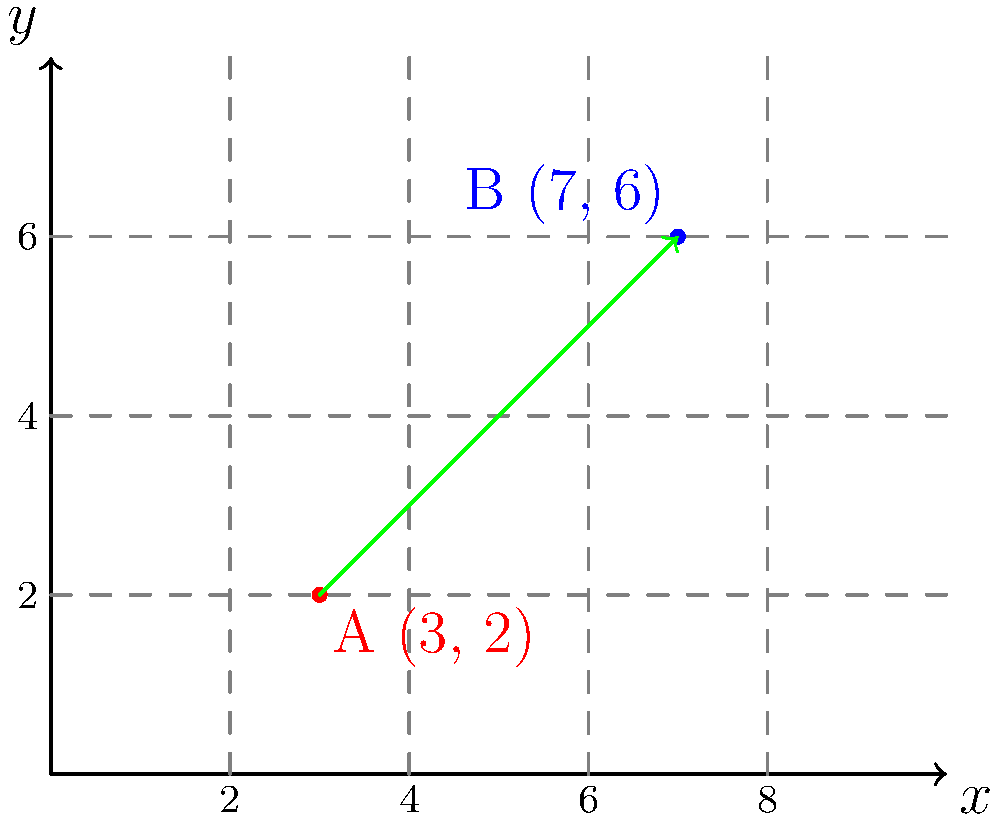Two historical weather stations, A and B, are located on a map with vector coordinates A(3, 2) and B(7, 6) respectively. Calculate the distance between these two stations using the given coordinates. To calculate the distance between two points on a coordinate plane, we can use the distance formula, which is derived from the Pythagorean theorem:

$d = \sqrt{(x_2 - x_1)^2 + (y_2 - y_1)^2}$

Where $(x_1, y_1)$ are the coordinates of the first point and $(x_2, y_2)$ are the coordinates of the second point.

Let's solve this step by step:

1) Identify the coordinates:
   Point A: $(x_1, y_1) = (3, 2)$
   Point B: $(x_2, y_2) = (7, 6)$

2) Plug these into the distance formula:
   $d = \sqrt{(7 - 3)^2 + (6 - 2)^2}$

3) Simplify inside the parentheses:
   $d = \sqrt{4^2 + 4^2}$

4) Calculate the squares:
   $d = \sqrt{16 + 16}$

5) Add inside the square root:
   $d = \sqrt{32}$

6) Simplify the square root:
   $d = 4\sqrt{2}$

Therefore, the distance between the two weather stations is $4\sqrt{2}$ units.
Answer: $4\sqrt{2}$ units 